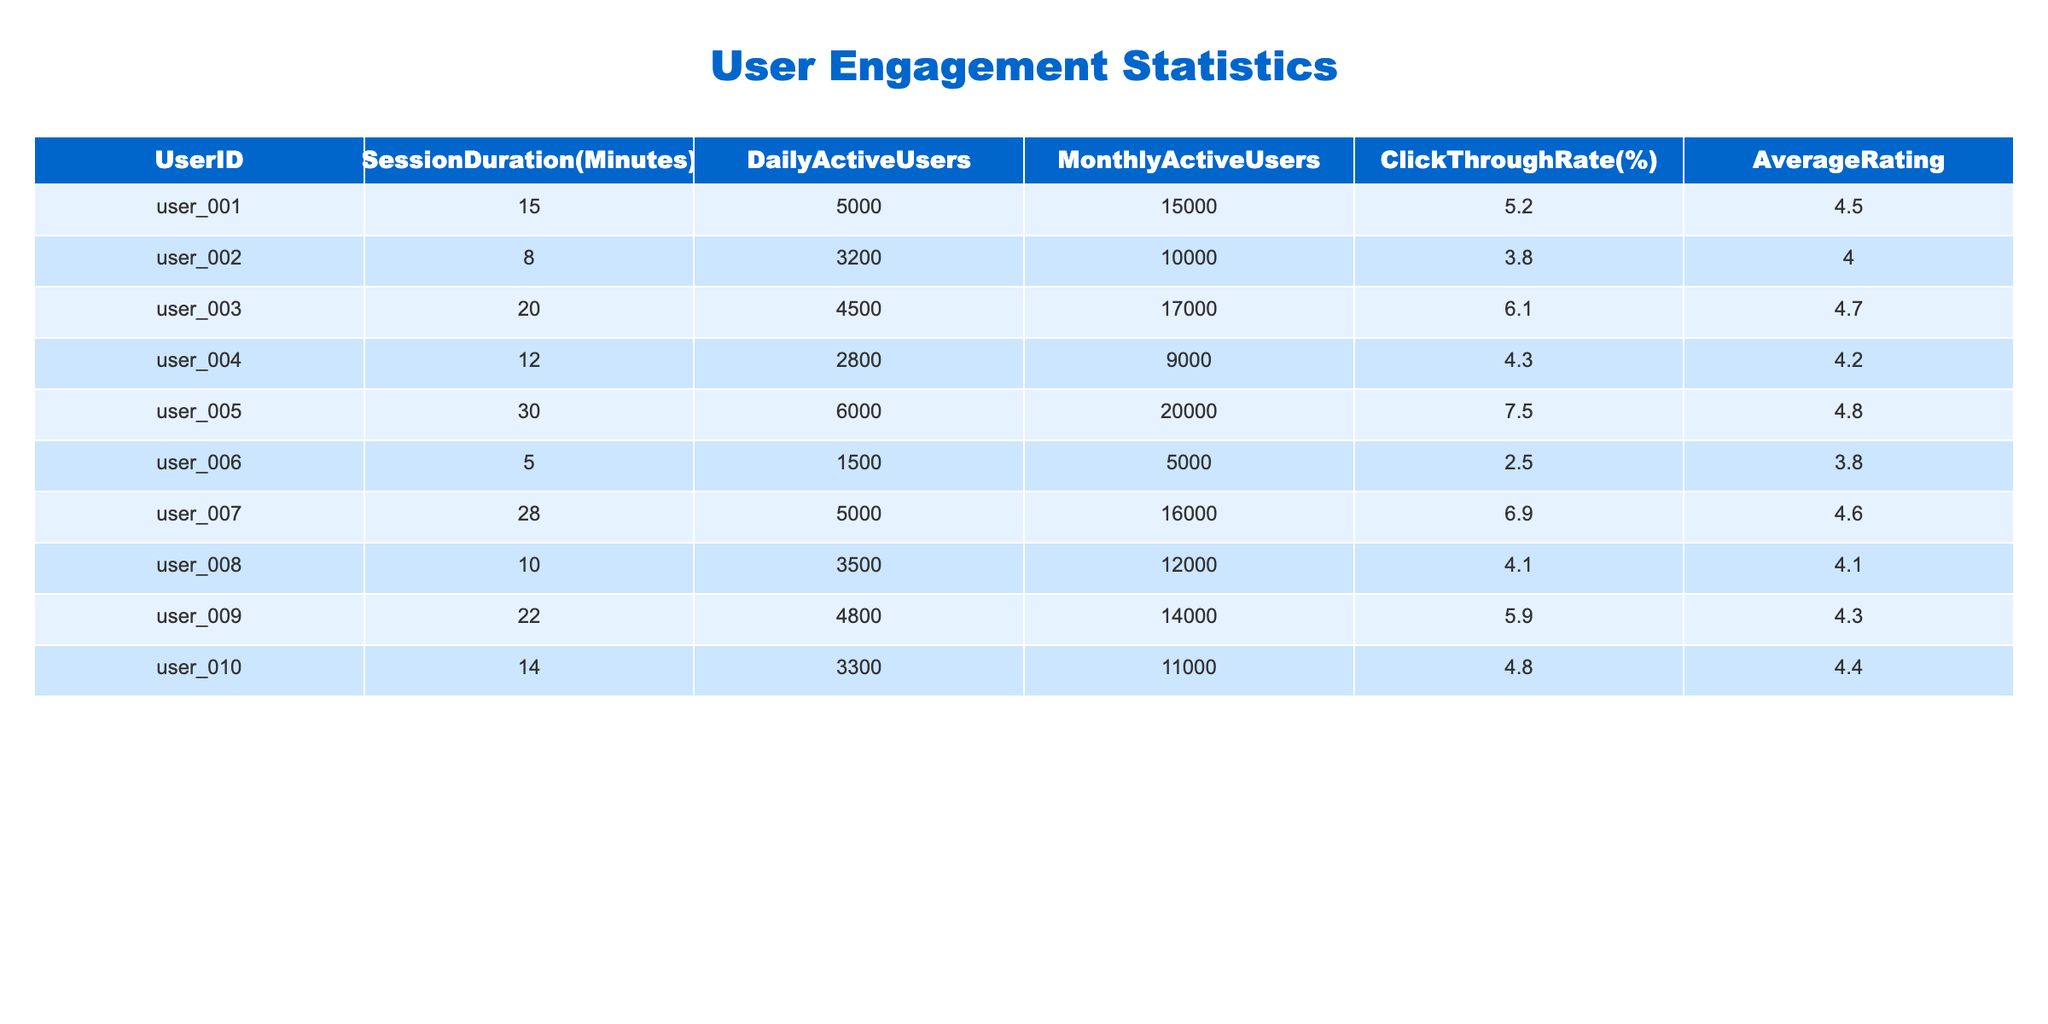What is the average session duration for all users? To find the average session duration, sum all the session durations (15 + 8 + 20 + 12 + 30 + 5 + 28 + 10 + 22 + 14) =  170 minutes. There are 10 users, so divide 170 by 10 to get the average, which is 17 minutes.
Answer: 17 minutes Which user has the highest click-through rate? By looking at the click-through rates, user_005 has the highest value at 7.5%.
Answer: user_005 Is the average rating of user_006 below 4.0? User_006 has an average rating of 3.8, which is below 4.0, confirming the statement as true.
Answer: True What is the total number of daily active users across all users? To find the total daily active users, sum the daily active users: (5000 + 3200 + 4500 + 2800 + 6000 + 1500 + 5000 + 3500 + 4800 + 3300) =  45000 daily active users.
Answer: 45000 What is the difference between the maximum and minimum session duration? The maximum session duration is 30 minutes (user_005) and the minimum session duration is 5 minutes (user_006). The difference is 30 - 5 = 25 minutes.
Answer: 25 minutes What percentage of users have an average rating above 4.5? There are 4 users (user_001, user_003, user_005, user_007) with an average rating above 4.5 out of 10 users total. Therefore, (4/10)*100 = 40%.
Answer: 40% What is the total number of monthly active users for users with a session duration greater than 15 minutes? The affected users are user_003, user_005, user_007, and user_009. Their monthly active users are 17000 + 20000 + 16000 + 14000 = 67000.
Answer: 67000 Are there more users with a click-through rate above 5% than below? Users with a click-through rate above 5% are user_005, user_007, and user_003 (3 users), while those below are user_001, user_002, user_004, user_006, user_008, user_009, user_010 (7 users). Thus, there are more below 5%.
Answer: False What is the average click-through rate for users with a session duration of more than 15 minutes? The users are user_003, user_005, user_007, and user_009, with click-through rates of 6.1, 7.5, 6.9, and 5.9 respectively. The average is (6.1 + 7.5 + 6.9 + 5.9)/4 = 6.35%.
Answer: 6.35% Which user has the lowest average rating? By checking the ratings, user_006 has the lowest average rating at 3.8.
Answer: user_006 